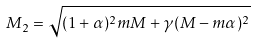<formula> <loc_0><loc_0><loc_500><loc_500>M _ { 2 } = \sqrt { ( 1 + \alpha ) ^ { 2 } m M + \gamma ( M - m \alpha ) ^ { 2 } }</formula> 